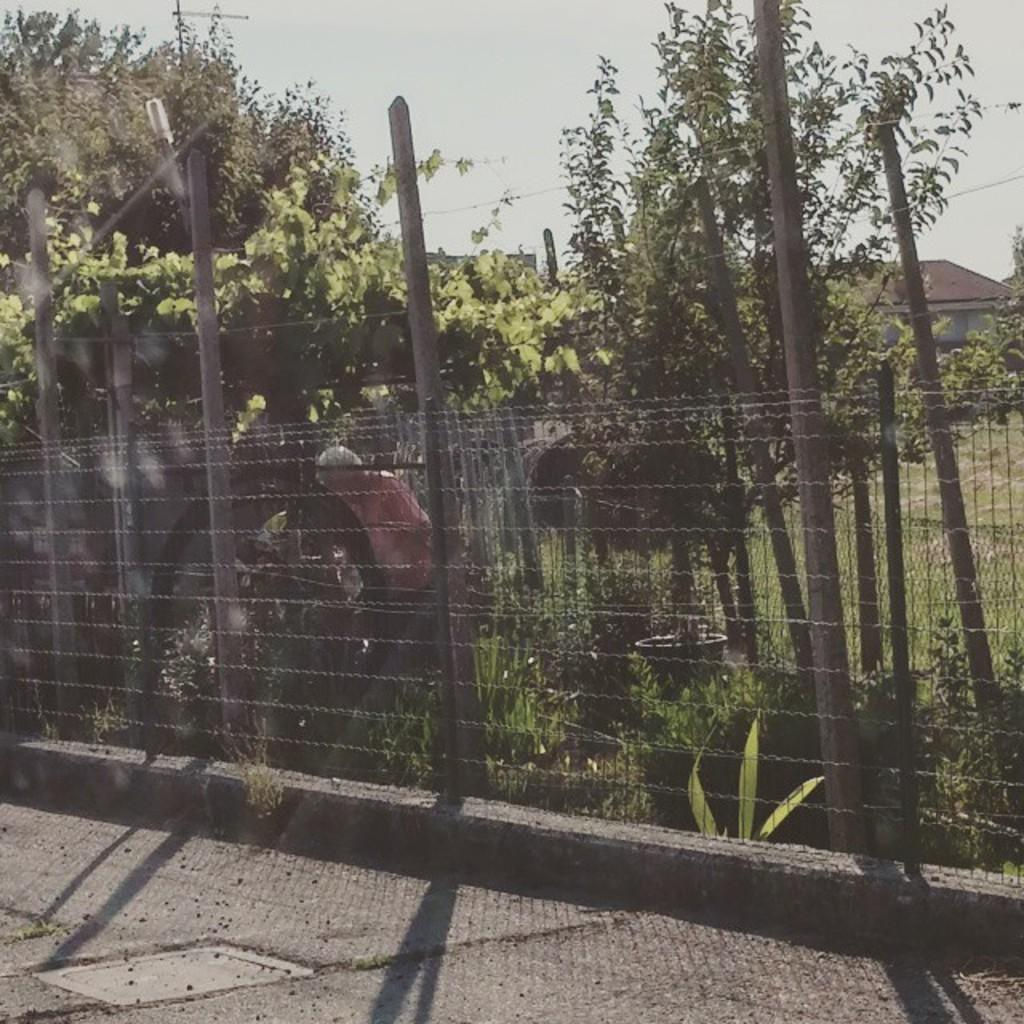What is the main feature of the image? There is a road in the image. What else can be seen along the road? There is a fence, poles, and a person in the image. What type of vegetation is present in the image? There are trees, plants, and grass on the ground in the image. What can be seen in the background of the image? There is a house, a roof, and the sky visible in the background of the image. What type of lace is being used to decorate the person's clothing in the image? There is no lace visible on the person's clothing in the image. What type of bone is being used as a decorative element in the image? There are no bones present in the image. 